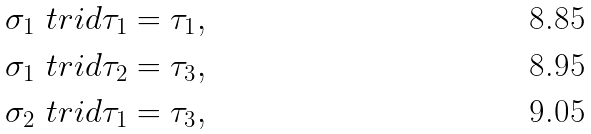<formula> <loc_0><loc_0><loc_500><loc_500>\sigma _ { 1 } \ t r i d \tau _ { 1 } & = \tau _ { 1 } , \\ \sigma _ { 1 } \ t r i d \tau _ { 2 } & = \tau _ { 3 } , \\ \sigma _ { 2 } \ t r i d \tau _ { 1 } & = \tau _ { 3 } ,</formula> 